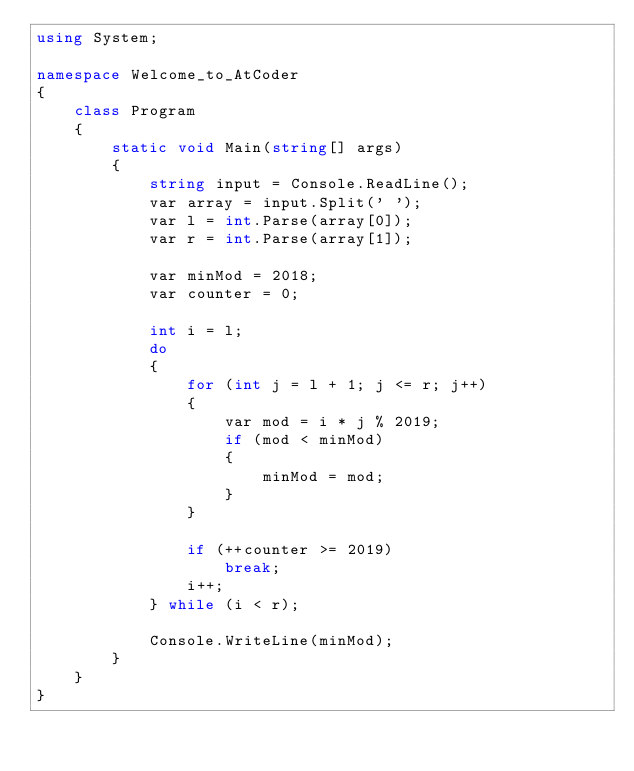Convert code to text. <code><loc_0><loc_0><loc_500><loc_500><_C#_>using System;

namespace Welcome_to_AtCoder
{
    class Program
    {
        static void Main(string[] args)
        {
            string input = Console.ReadLine();
            var array = input.Split(' ');
            var l = int.Parse(array[0]);
            var r = int.Parse(array[1]);

            var minMod = 2018;
            var counter = 0;

            int i = l;
            do
            {
                for (int j = l + 1; j <= r; j++)
                {
                    var mod = i * j % 2019;
                    if (mod < minMod)
                    {
                        minMod = mod;
                    }
                }

                if (++counter >= 2019)
                    break;
                i++;
            } while (i < r);

            Console.WriteLine(minMod);
        }
    }
}
</code> 